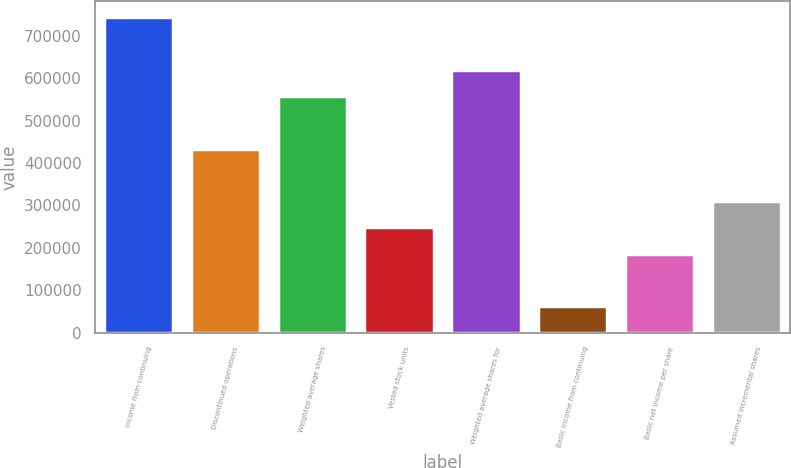<chart> <loc_0><loc_0><loc_500><loc_500><bar_chart><fcel>Income from continuing<fcel>Discontinued operations<fcel>Weighted average shares<fcel>Vested stock units<fcel>Weighted average shares for<fcel>Basic income from continuing<fcel>Basic net income per share<fcel>Assumed incremental shares<nl><fcel>744236<fcel>434139<fcel>558178<fcel>248081<fcel>620197<fcel>62022.3<fcel>186061<fcel>310100<nl></chart> 